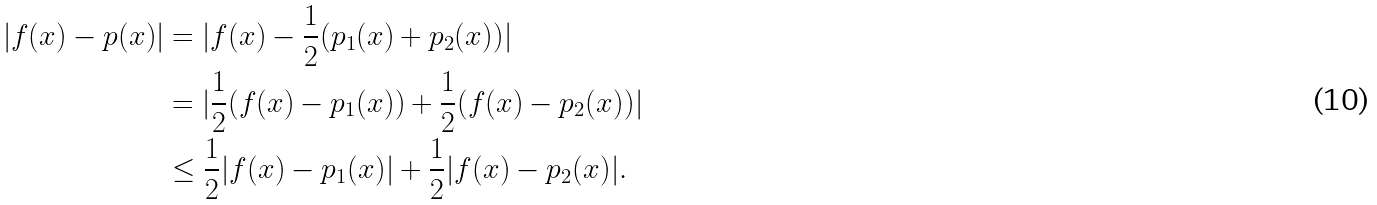<formula> <loc_0><loc_0><loc_500><loc_500>| f ( x ) - p ( x ) | & = | f ( x ) - \frac { 1 } { 2 } ( p _ { 1 } ( x ) + p _ { 2 } ( x ) ) | \\ & = | \frac { 1 } { 2 } ( f ( x ) - p _ { 1 } ( x ) ) + \frac { 1 } { 2 } ( f ( x ) - p _ { 2 } ( x ) ) | \\ & \leq \frac { 1 } { 2 } | f ( x ) - p _ { 1 } ( x ) | + \frac { 1 } { 2 } | f ( x ) - p _ { 2 } ( x ) | .</formula> 